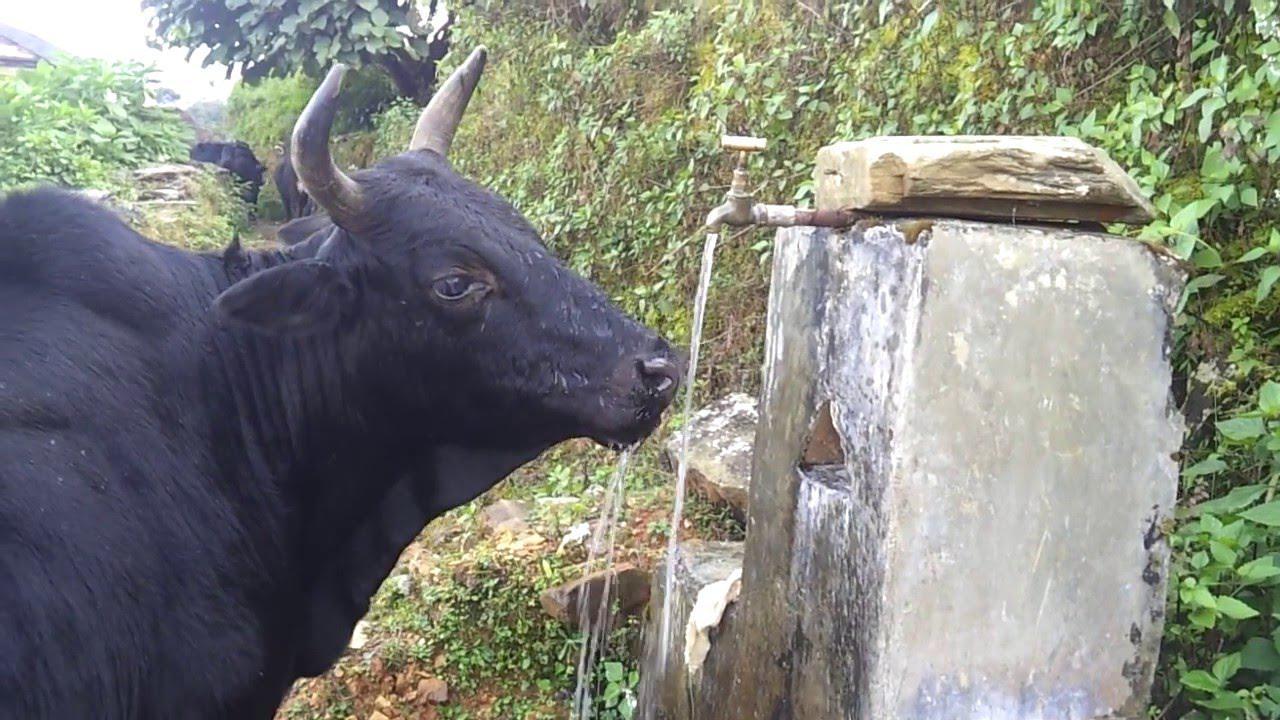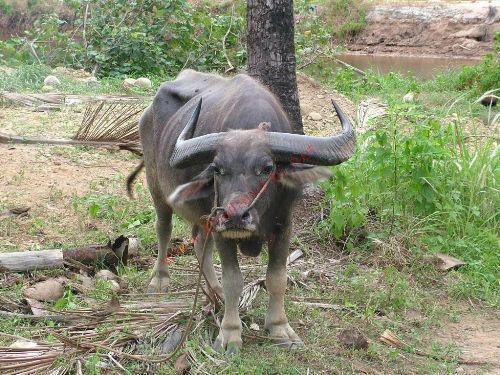The first image is the image on the left, the second image is the image on the right. For the images shown, is this caption "there are 2 bulls" true? Answer yes or no. Yes. 